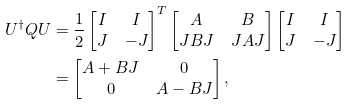<formula> <loc_0><loc_0><loc_500><loc_500>U ^ { \dag } Q U & = \frac { 1 } { 2 } \begin{bmatrix} I & I \\ J & - J \end{bmatrix} ^ { T } \begin{bmatrix} A & B \\ J B J & J A J \end{bmatrix} \begin{bmatrix} I & I \\ J & - J \end{bmatrix} \\ & = \begin{bmatrix} A + B J & 0 \\ 0 & A - B J \end{bmatrix} ,</formula> 